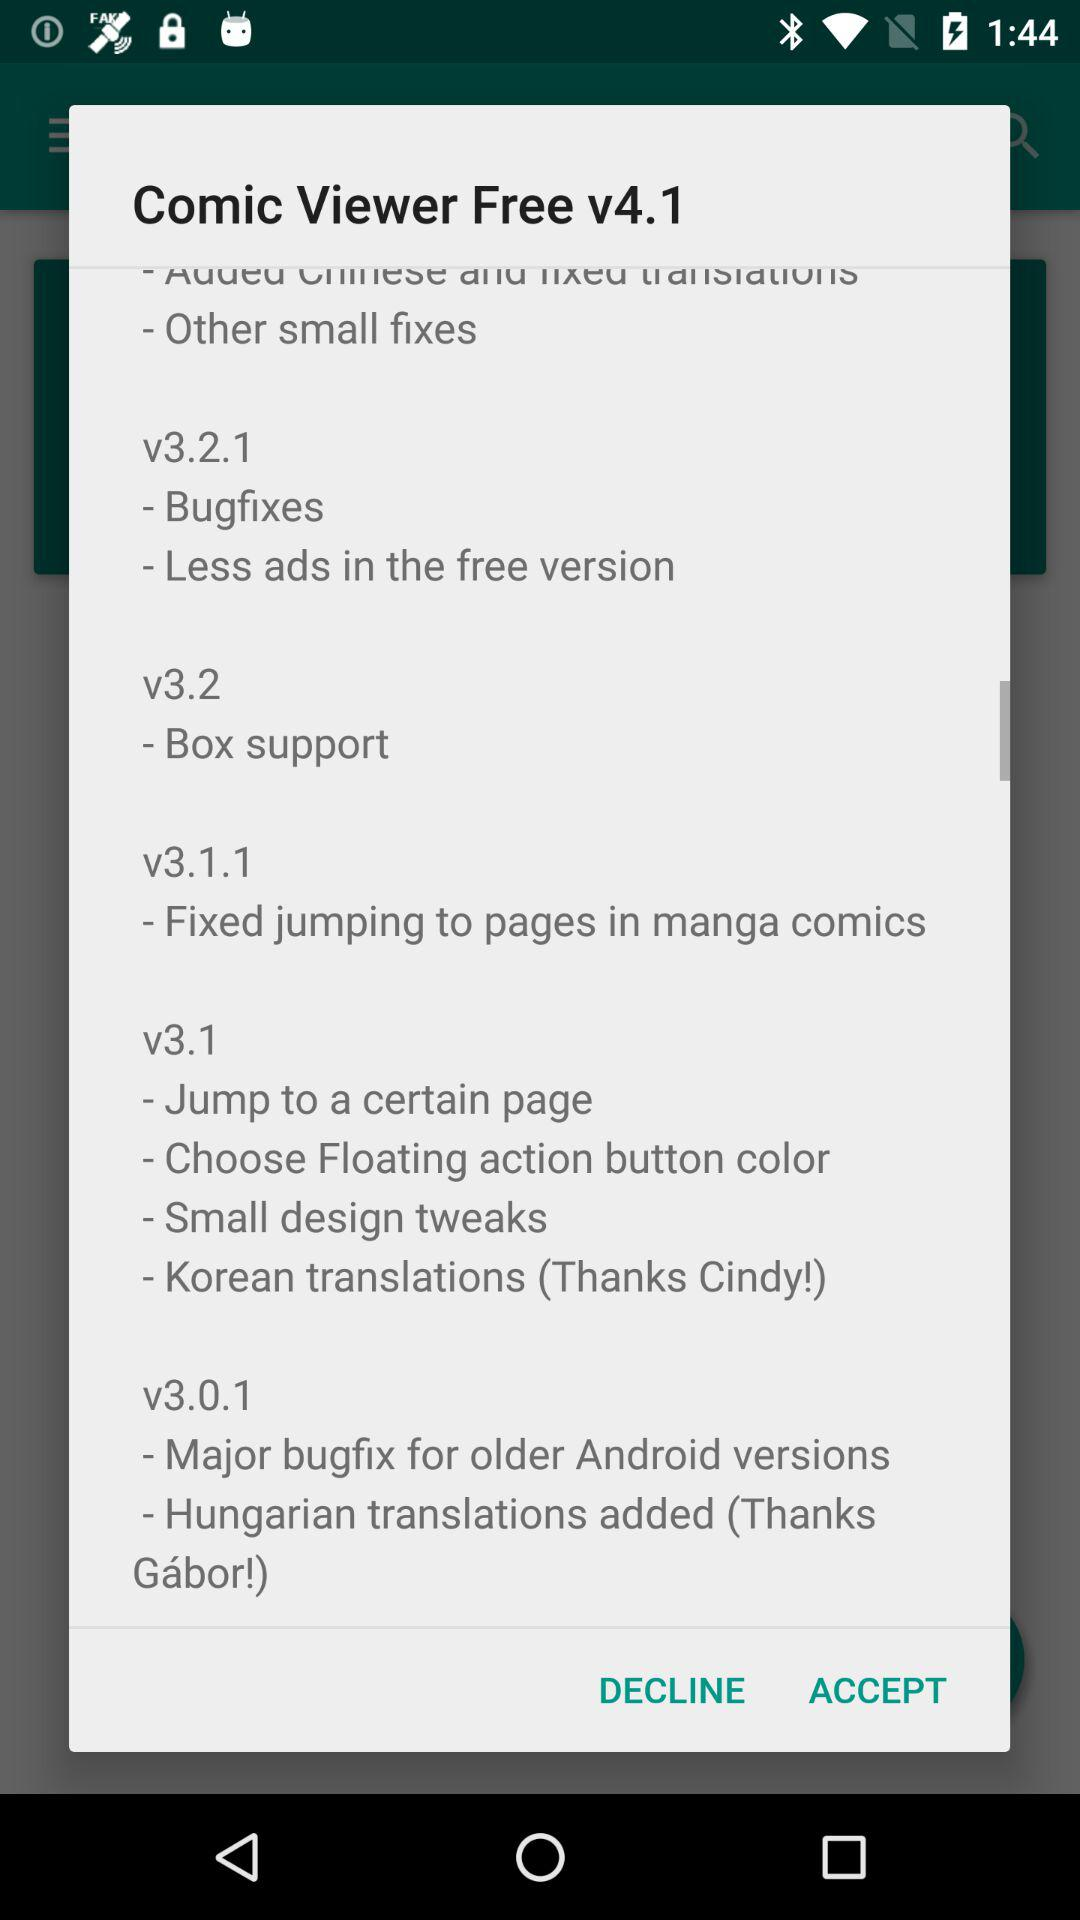What is the version of the application? The version of the application is v4.1. 